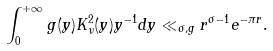<formula> <loc_0><loc_0><loc_500><loc_500>\int ^ { + \infty } _ { 0 } g ( y ) K ^ { 2 } _ { \nu } ( y ) y ^ { - 1 } d y \ll _ { \sigma , g } r ^ { \sigma - 1 } e ^ { - \pi r } .</formula> 